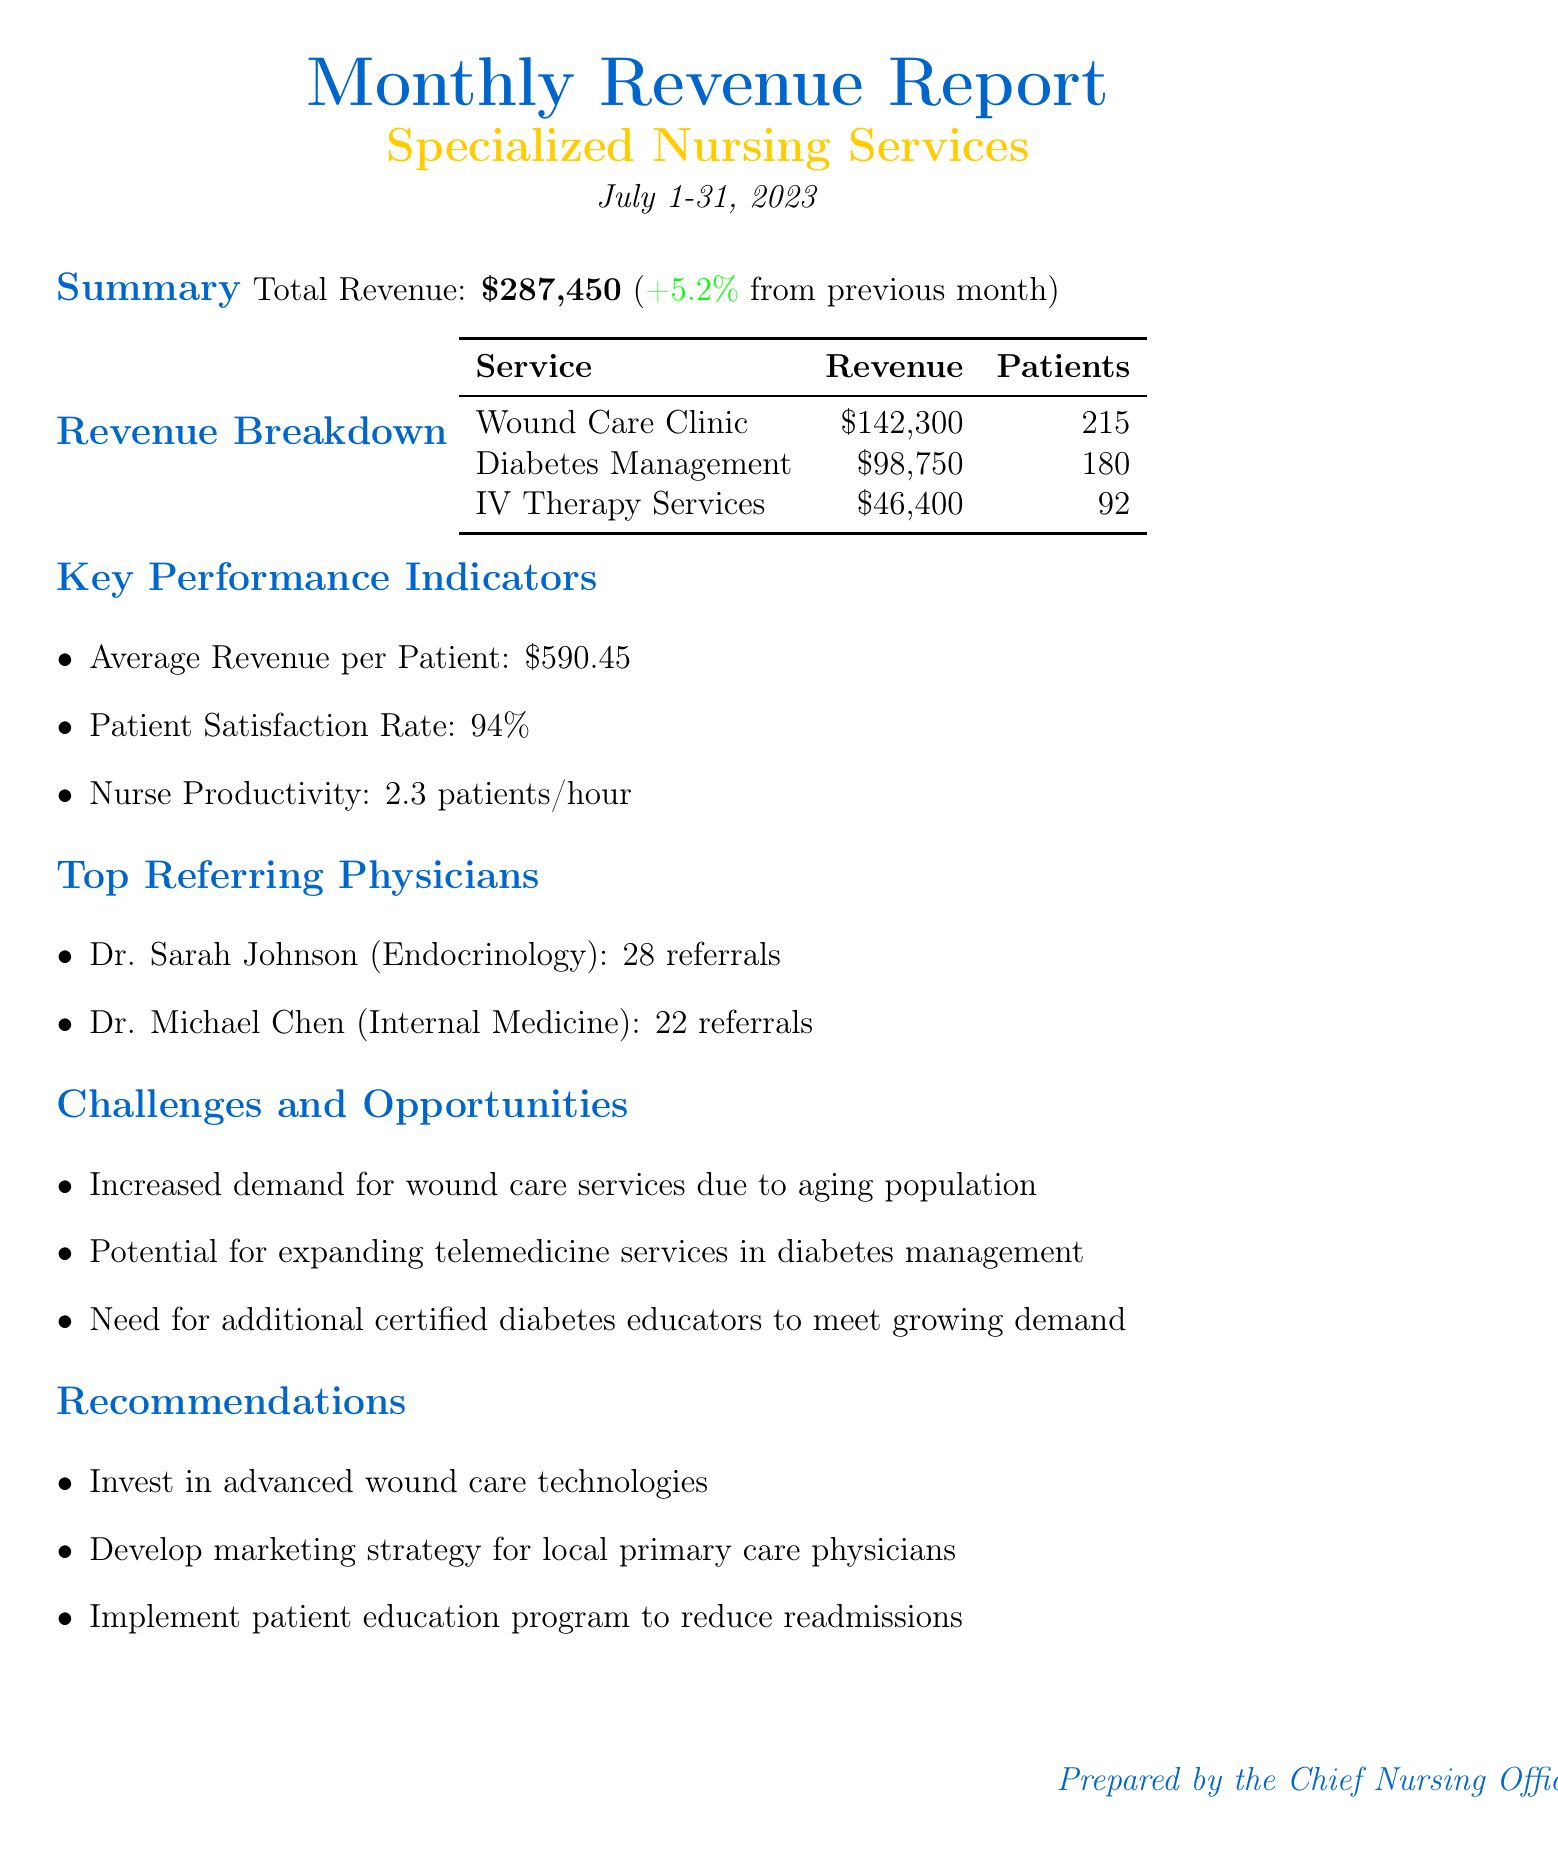What is the total revenue for July 2023? The total revenue is presented in the summary section of the document, amounting to $287,450.
Answer: $287,450 How much revenue was generated from the Wound Care Clinic? The revenue breakdown section lists the revenue specifically for the Wound Care Clinic, which is $142,300.
Answer: $142,300 What was the percent change in revenue from the previous month? The summary section mentions a percent change of +5.2%, indicating an increase from last month.
Answer: +5.2% How many patients were served by the Diabetes Management Program? The revenue breakdown includes the number of patients served for the Diabetes Management Program, which is 180.
Answer: 180 What is the patient satisfaction rate reported? The key performance indicators section states the patient satisfaction rate as 94%.
Answer: 94% What opportunity is mentioned regarding diabetes management? The challenges and opportunities section suggests the potential for expanding telemedicine services in diabetes management.
Answer: Expanding telemedicine services Who referred the most patients to specialized nursing services? The top referring physicians section indicates that Dr. Sarah Johnson referred the most patients, with 28 referrals.
Answer: Dr. Sarah Johnson What does the report recommend to reduce readmission rates? The recommendations section suggests implementing a patient education program to reduce readmission rates.
Answer: Implement a patient education program What is the average revenue per patient? The key performance indicators section specifies that the average revenue per patient is $590.45.
Answer: $590.45 